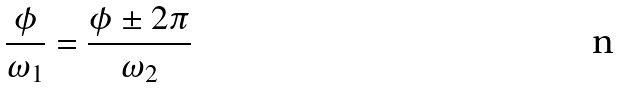Convert formula to latex. <formula><loc_0><loc_0><loc_500><loc_500>\frac { \phi } { \omega _ { 1 } } = \frac { \phi \pm 2 \pi } { \omega _ { 2 } }</formula> 